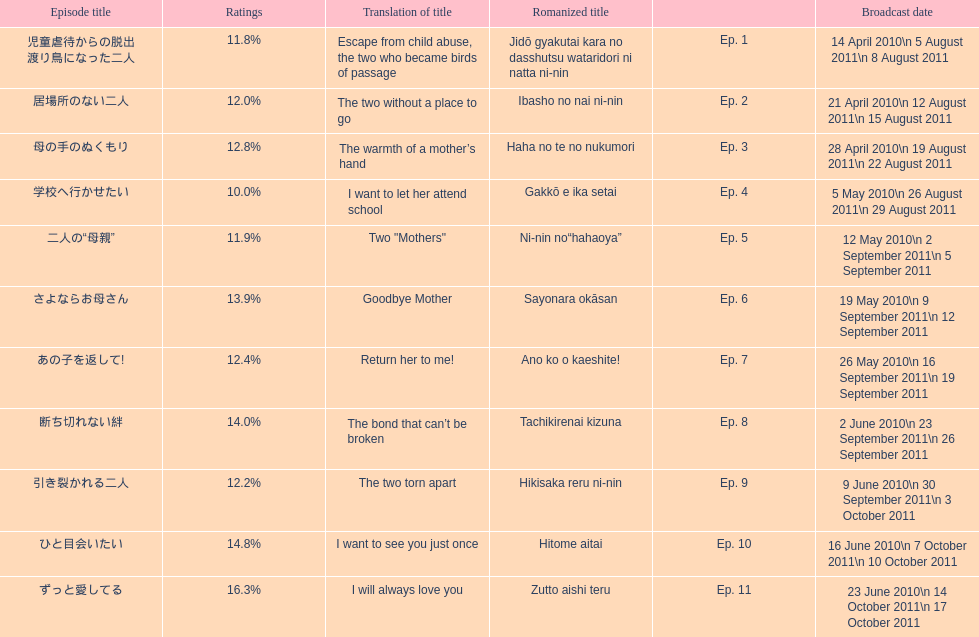What are the rating percentages for each episode? 11.8%, 12.0%, 12.8%, 10.0%, 11.9%, 13.9%, 12.4%, 14.0%, 12.2%, 14.8%, 16.3%. What is the highest rating an episode got? 16.3%. What episode got a rating of 16.3%? ずっと愛してる. 